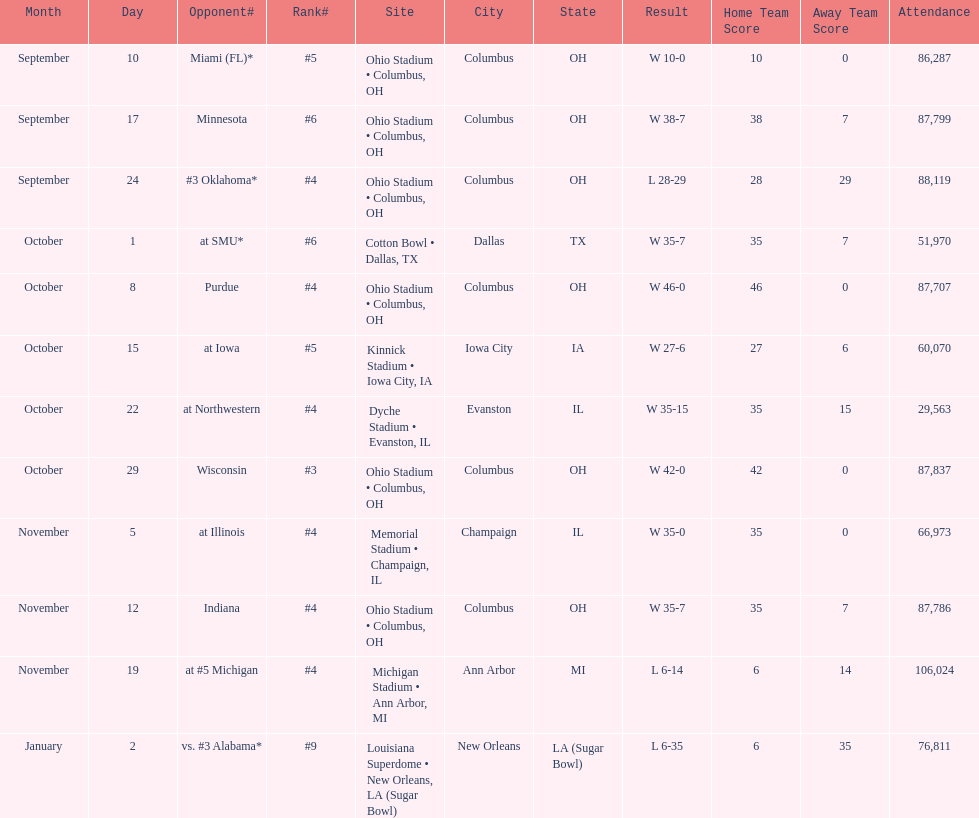Which date was attended by the most people? November 19. 